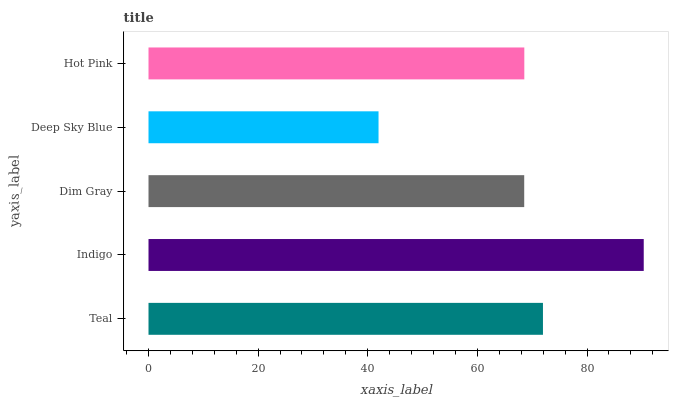Is Deep Sky Blue the minimum?
Answer yes or no. Yes. Is Indigo the maximum?
Answer yes or no. Yes. Is Dim Gray the minimum?
Answer yes or no. No. Is Dim Gray the maximum?
Answer yes or no. No. Is Indigo greater than Dim Gray?
Answer yes or no. Yes. Is Dim Gray less than Indigo?
Answer yes or no. Yes. Is Dim Gray greater than Indigo?
Answer yes or no. No. Is Indigo less than Dim Gray?
Answer yes or no. No. Is Hot Pink the high median?
Answer yes or no. Yes. Is Hot Pink the low median?
Answer yes or no. Yes. Is Indigo the high median?
Answer yes or no. No. Is Indigo the low median?
Answer yes or no. No. 